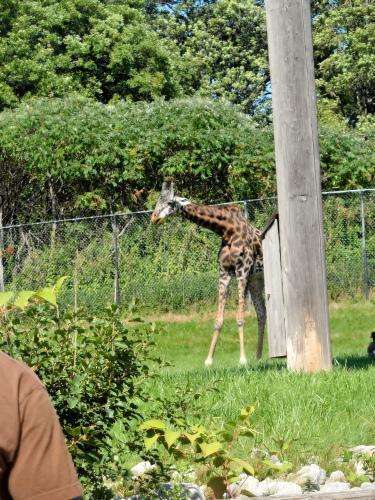How many giraffes are there?
Give a very brief answer. 1. How many bananas is the woman holding?
Give a very brief answer. 0. 